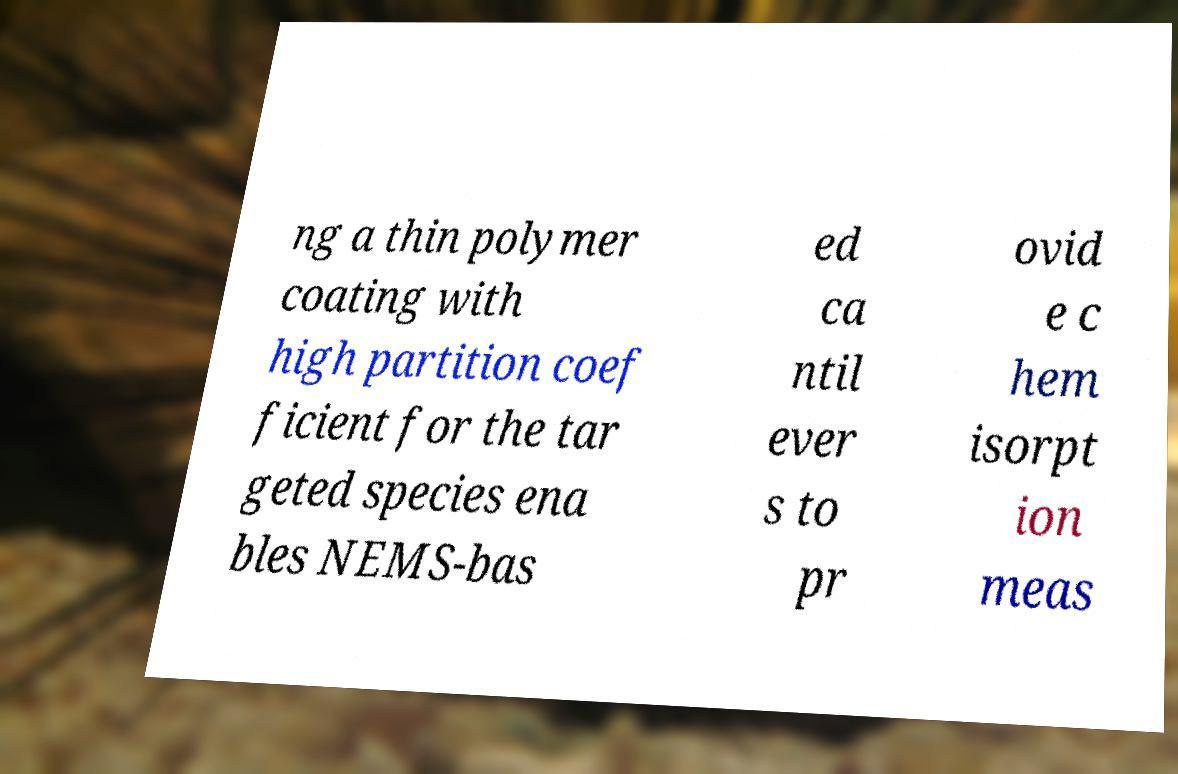What messages or text are displayed in this image? I need them in a readable, typed format. ng a thin polymer coating with high partition coef ficient for the tar geted species ena bles NEMS-bas ed ca ntil ever s to pr ovid e c hem isorpt ion meas 